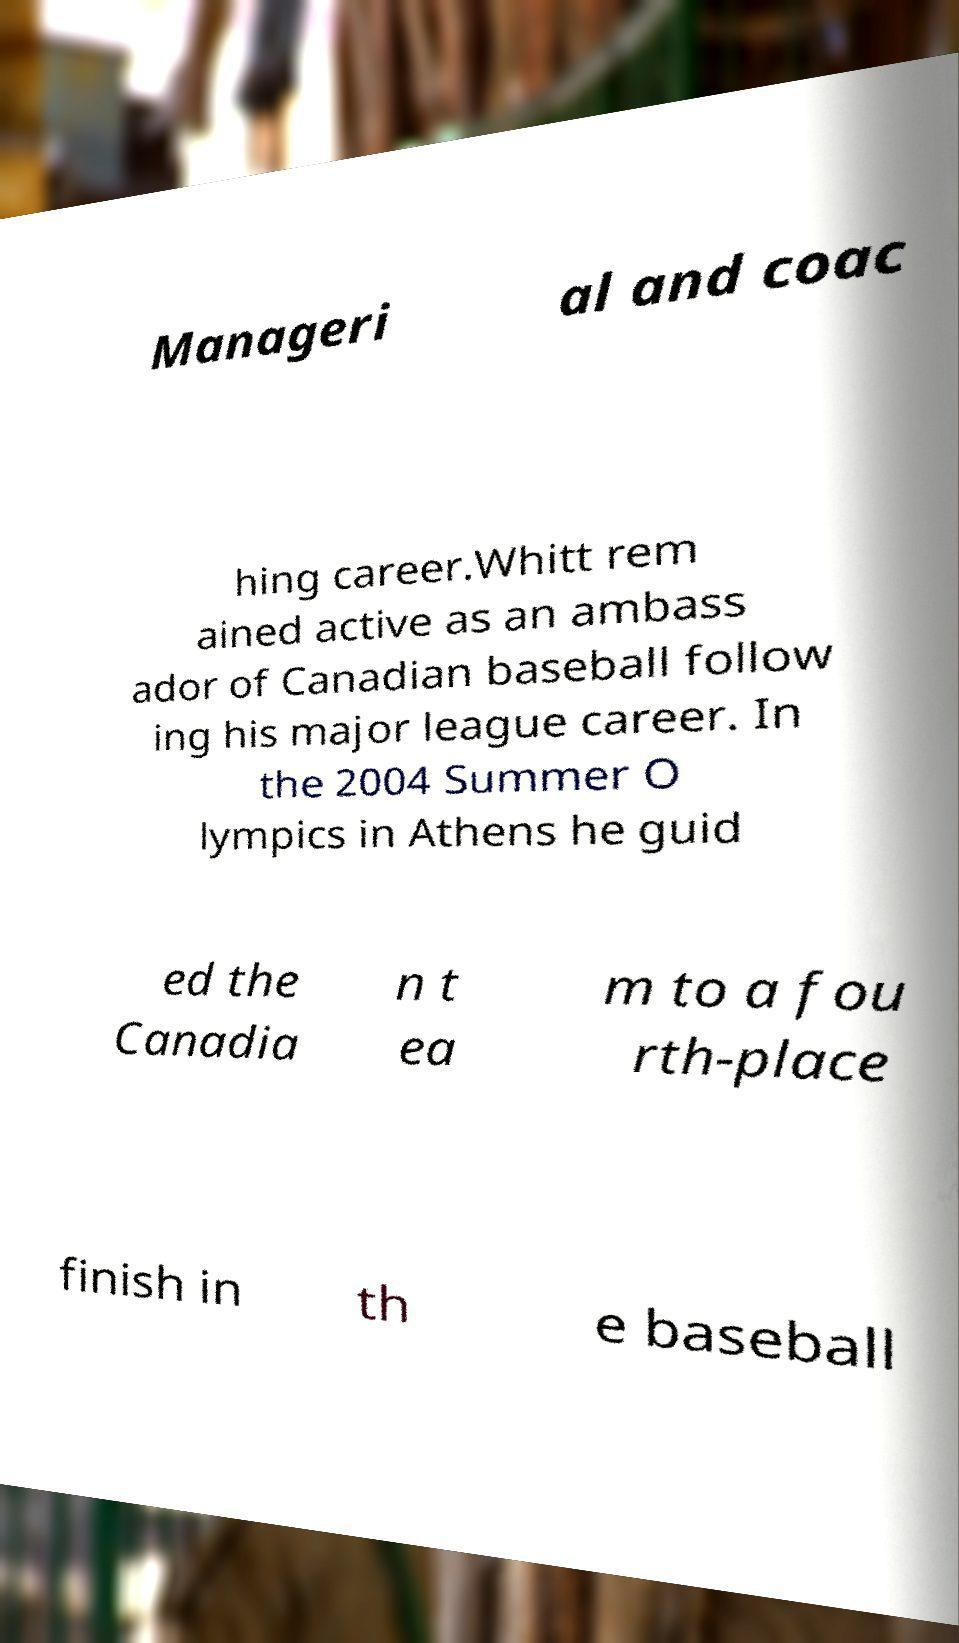What messages or text are displayed in this image? I need them in a readable, typed format. Manageri al and coac hing career.Whitt rem ained active as an ambass ador of Canadian baseball follow ing his major league career. In the 2004 Summer O lympics in Athens he guid ed the Canadia n t ea m to a fou rth-place finish in th e baseball 